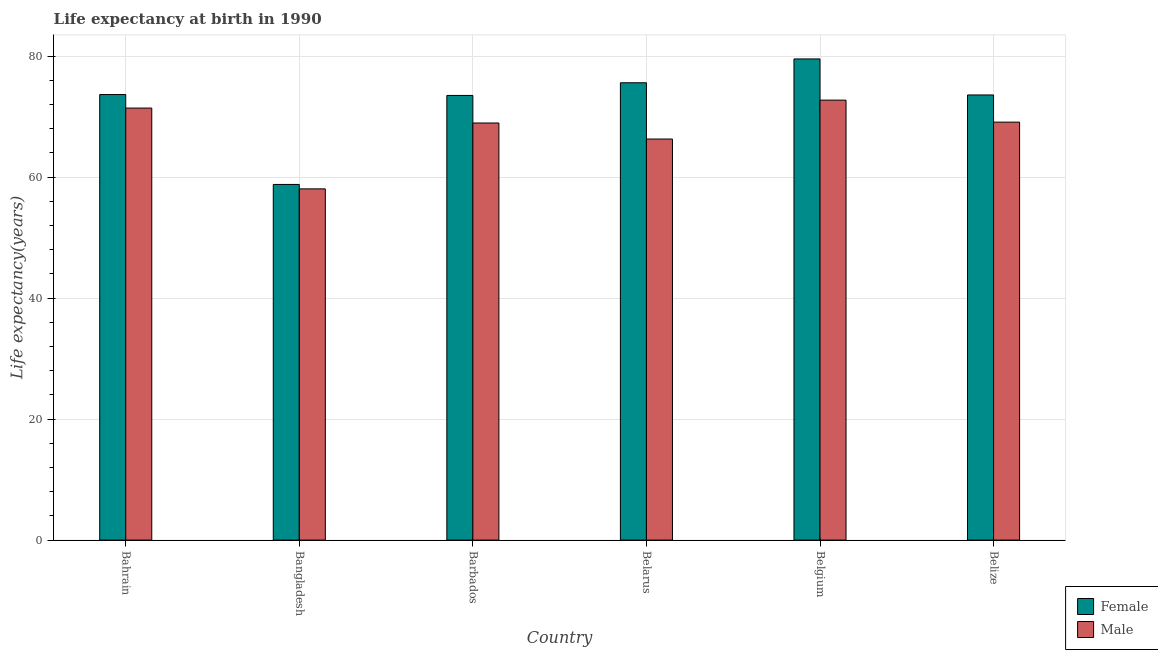Are the number of bars per tick equal to the number of legend labels?
Offer a very short reply. Yes. Are the number of bars on each tick of the X-axis equal?
Provide a short and direct response. Yes. How many bars are there on the 6th tick from the left?
Offer a terse response. 2. How many bars are there on the 3rd tick from the right?
Make the answer very short. 2. What is the label of the 4th group of bars from the left?
Offer a terse response. Belarus. What is the life expectancy(female) in Barbados?
Your answer should be very brief. 73.5. Across all countries, what is the maximum life expectancy(female)?
Provide a short and direct response. 79.54. Across all countries, what is the minimum life expectancy(male)?
Provide a short and direct response. 58.06. In which country was the life expectancy(female) minimum?
Your answer should be compact. Bangladesh. What is the total life expectancy(female) in the graph?
Provide a succinct answer. 434.67. What is the difference between the life expectancy(female) in Bangladesh and that in Belgium?
Make the answer very short. -20.75. What is the difference between the life expectancy(female) in Bangladesh and the life expectancy(male) in Belarus?
Make the answer very short. -7.51. What is the average life expectancy(male) per country?
Make the answer very short. 67.76. What is the difference between the life expectancy(female) and life expectancy(male) in Barbados?
Offer a terse response. 4.55. In how many countries, is the life expectancy(female) greater than 40 years?
Give a very brief answer. 6. What is the ratio of the life expectancy(male) in Bangladesh to that in Belize?
Your answer should be very brief. 0.84. What is the difference between the highest and the second highest life expectancy(male)?
Your response must be concise. 1.31. What is the difference between the highest and the lowest life expectancy(female)?
Keep it short and to the point. 20.75. Is the sum of the life expectancy(female) in Bangladesh and Barbados greater than the maximum life expectancy(male) across all countries?
Your answer should be compact. Yes. What does the 2nd bar from the left in Belgium represents?
Your response must be concise. Male. What does the 2nd bar from the right in Belarus represents?
Make the answer very short. Female. How many bars are there?
Your answer should be compact. 12. Are all the bars in the graph horizontal?
Keep it short and to the point. No. How many countries are there in the graph?
Offer a terse response. 6. What is the difference between two consecutive major ticks on the Y-axis?
Provide a succinct answer. 20. Are the values on the major ticks of Y-axis written in scientific E-notation?
Offer a terse response. No. Does the graph contain any zero values?
Provide a succinct answer. No. Does the graph contain grids?
Offer a terse response. Yes. Where does the legend appear in the graph?
Make the answer very short. Bottom right. What is the title of the graph?
Provide a succinct answer. Life expectancy at birth in 1990. What is the label or title of the X-axis?
Ensure brevity in your answer.  Country. What is the label or title of the Y-axis?
Your answer should be compact. Life expectancy(years). What is the Life expectancy(years) in Female in Bahrain?
Offer a very short reply. 73.65. What is the Life expectancy(years) of Male in Bahrain?
Make the answer very short. 71.42. What is the Life expectancy(years) in Female in Bangladesh?
Make the answer very short. 58.79. What is the Life expectancy(years) of Male in Bangladesh?
Offer a very short reply. 58.06. What is the Life expectancy(years) of Female in Barbados?
Offer a terse response. 73.5. What is the Life expectancy(years) in Male in Barbados?
Offer a terse response. 68.95. What is the Life expectancy(years) in Female in Belarus?
Ensure brevity in your answer.  75.6. What is the Life expectancy(years) of Male in Belarus?
Give a very brief answer. 66.3. What is the Life expectancy(years) in Female in Belgium?
Provide a succinct answer. 79.54. What is the Life expectancy(years) in Male in Belgium?
Your answer should be compact. 72.73. What is the Life expectancy(years) of Female in Belize?
Offer a very short reply. 73.58. What is the Life expectancy(years) in Male in Belize?
Provide a short and direct response. 69.09. Across all countries, what is the maximum Life expectancy(years) of Female?
Give a very brief answer. 79.54. Across all countries, what is the maximum Life expectancy(years) in Male?
Give a very brief answer. 72.73. Across all countries, what is the minimum Life expectancy(years) of Female?
Offer a very short reply. 58.79. Across all countries, what is the minimum Life expectancy(years) in Male?
Offer a very short reply. 58.06. What is the total Life expectancy(years) in Female in the graph?
Keep it short and to the point. 434.67. What is the total Life expectancy(years) of Male in the graph?
Give a very brief answer. 406.55. What is the difference between the Life expectancy(years) of Female in Bahrain and that in Bangladesh?
Provide a succinct answer. 14.86. What is the difference between the Life expectancy(years) of Male in Bahrain and that in Bangladesh?
Your response must be concise. 13.36. What is the difference between the Life expectancy(years) in Female in Bahrain and that in Barbados?
Your answer should be compact. 0.15. What is the difference between the Life expectancy(years) in Male in Bahrain and that in Barbados?
Give a very brief answer. 2.47. What is the difference between the Life expectancy(years) in Female in Bahrain and that in Belarus?
Make the answer very short. -1.95. What is the difference between the Life expectancy(years) in Male in Bahrain and that in Belarus?
Your answer should be very brief. 5.12. What is the difference between the Life expectancy(years) in Female in Bahrain and that in Belgium?
Provide a succinct answer. -5.89. What is the difference between the Life expectancy(years) of Male in Bahrain and that in Belgium?
Keep it short and to the point. -1.31. What is the difference between the Life expectancy(years) of Female in Bahrain and that in Belize?
Your answer should be very brief. 0.07. What is the difference between the Life expectancy(years) in Male in Bahrain and that in Belize?
Your response must be concise. 2.32. What is the difference between the Life expectancy(years) in Female in Bangladesh and that in Barbados?
Offer a very short reply. -14.71. What is the difference between the Life expectancy(years) in Male in Bangladesh and that in Barbados?
Your answer should be very brief. -10.89. What is the difference between the Life expectancy(years) in Female in Bangladesh and that in Belarus?
Your answer should be very brief. -16.81. What is the difference between the Life expectancy(years) of Male in Bangladesh and that in Belarus?
Your answer should be compact. -8.24. What is the difference between the Life expectancy(years) in Female in Bangladesh and that in Belgium?
Your answer should be compact. -20.75. What is the difference between the Life expectancy(years) in Male in Bangladesh and that in Belgium?
Provide a succinct answer. -14.67. What is the difference between the Life expectancy(years) of Female in Bangladesh and that in Belize?
Your answer should be very brief. -14.79. What is the difference between the Life expectancy(years) in Male in Bangladesh and that in Belize?
Keep it short and to the point. -11.03. What is the difference between the Life expectancy(years) in Female in Barbados and that in Belarus?
Provide a short and direct response. -2.1. What is the difference between the Life expectancy(years) of Male in Barbados and that in Belarus?
Make the answer very short. 2.65. What is the difference between the Life expectancy(years) of Female in Barbados and that in Belgium?
Offer a very short reply. -6.04. What is the difference between the Life expectancy(years) of Male in Barbados and that in Belgium?
Your response must be concise. -3.78. What is the difference between the Life expectancy(years) of Female in Barbados and that in Belize?
Give a very brief answer. -0.08. What is the difference between the Life expectancy(years) in Male in Barbados and that in Belize?
Keep it short and to the point. -0.14. What is the difference between the Life expectancy(years) in Female in Belarus and that in Belgium?
Your answer should be very brief. -3.94. What is the difference between the Life expectancy(years) in Male in Belarus and that in Belgium?
Give a very brief answer. -6.43. What is the difference between the Life expectancy(years) of Female in Belarus and that in Belize?
Ensure brevity in your answer.  2.02. What is the difference between the Life expectancy(years) of Male in Belarus and that in Belize?
Give a very brief answer. -2.79. What is the difference between the Life expectancy(years) in Female in Belgium and that in Belize?
Keep it short and to the point. 5.96. What is the difference between the Life expectancy(years) of Male in Belgium and that in Belize?
Keep it short and to the point. 3.64. What is the difference between the Life expectancy(years) in Female in Bahrain and the Life expectancy(years) in Male in Bangladesh?
Offer a terse response. 15.59. What is the difference between the Life expectancy(years) in Female in Bahrain and the Life expectancy(years) in Male in Barbados?
Offer a terse response. 4.7. What is the difference between the Life expectancy(years) in Female in Bahrain and the Life expectancy(years) in Male in Belarus?
Ensure brevity in your answer.  7.35. What is the difference between the Life expectancy(years) in Female in Bahrain and the Life expectancy(years) in Male in Belgium?
Make the answer very short. 0.92. What is the difference between the Life expectancy(years) in Female in Bahrain and the Life expectancy(years) in Male in Belize?
Give a very brief answer. 4.56. What is the difference between the Life expectancy(years) of Female in Bangladesh and the Life expectancy(years) of Male in Barbados?
Your answer should be very brief. -10.16. What is the difference between the Life expectancy(years) of Female in Bangladesh and the Life expectancy(years) of Male in Belarus?
Your answer should be very brief. -7.51. What is the difference between the Life expectancy(years) of Female in Bangladesh and the Life expectancy(years) of Male in Belgium?
Provide a succinct answer. -13.94. What is the difference between the Life expectancy(years) in Female in Bangladesh and the Life expectancy(years) in Male in Belize?
Keep it short and to the point. -10.3. What is the difference between the Life expectancy(years) in Female in Barbados and the Life expectancy(years) in Male in Belarus?
Make the answer very short. 7.21. What is the difference between the Life expectancy(years) in Female in Barbados and the Life expectancy(years) in Male in Belgium?
Offer a very short reply. 0.78. What is the difference between the Life expectancy(years) of Female in Barbados and the Life expectancy(years) of Male in Belize?
Your answer should be very brief. 4.41. What is the difference between the Life expectancy(years) in Female in Belarus and the Life expectancy(years) in Male in Belgium?
Keep it short and to the point. 2.87. What is the difference between the Life expectancy(years) in Female in Belarus and the Life expectancy(years) in Male in Belize?
Your response must be concise. 6.51. What is the difference between the Life expectancy(years) in Female in Belgium and the Life expectancy(years) in Male in Belize?
Ensure brevity in your answer.  10.45. What is the average Life expectancy(years) in Female per country?
Give a very brief answer. 72.45. What is the average Life expectancy(years) of Male per country?
Your answer should be compact. 67.76. What is the difference between the Life expectancy(years) of Female and Life expectancy(years) of Male in Bahrain?
Offer a very short reply. 2.23. What is the difference between the Life expectancy(years) in Female and Life expectancy(years) in Male in Bangladesh?
Keep it short and to the point. 0.73. What is the difference between the Life expectancy(years) in Female and Life expectancy(years) in Male in Barbados?
Provide a succinct answer. 4.55. What is the difference between the Life expectancy(years) of Female and Life expectancy(years) of Male in Belgium?
Ensure brevity in your answer.  6.81. What is the difference between the Life expectancy(years) of Female and Life expectancy(years) of Male in Belize?
Offer a very short reply. 4.49. What is the ratio of the Life expectancy(years) of Female in Bahrain to that in Bangladesh?
Keep it short and to the point. 1.25. What is the ratio of the Life expectancy(years) in Male in Bahrain to that in Bangladesh?
Ensure brevity in your answer.  1.23. What is the ratio of the Life expectancy(years) in Female in Bahrain to that in Barbados?
Keep it short and to the point. 1. What is the ratio of the Life expectancy(years) in Male in Bahrain to that in Barbados?
Make the answer very short. 1.04. What is the ratio of the Life expectancy(years) in Female in Bahrain to that in Belarus?
Your answer should be compact. 0.97. What is the ratio of the Life expectancy(years) of Male in Bahrain to that in Belarus?
Keep it short and to the point. 1.08. What is the ratio of the Life expectancy(years) of Female in Bahrain to that in Belgium?
Your answer should be compact. 0.93. What is the ratio of the Life expectancy(years) in Male in Bahrain to that in Belgium?
Ensure brevity in your answer.  0.98. What is the ratio of the Life expectancy(years) in Male in Bahrain to that in Belize?
Provide a succinct answer. 1.03. What is the ratio of the Life expectancy(years) of Female in Bangladesh to that in Barbados?
Offer a terse response. 0.8. What is the ratio of the Life expectancy(years) in Male in Bangladesh to that in Barbados?
Give a very brief answer. 0.84. What is the ratio of the Life expectancy(years) in Female in Bangladesh to that in Belarus?
Keep it short and to the point. 0.78. What is the ratio of the Life expectancy(years) in Male in Bangladesh to that in Belarus?
Provide a short and direct response. 0.88. What is the ratio of the Life expectancy(years) of Female in Bangladesh to that in Belgium?
Your answer should be very brief. 0.74. What is the ratio of the Life expectancy(years) in Male in Bangladesh to that in Belgium?
Offer a terse response. 0.8. What is the ratio of the Life expectancy(years) in Female in Bangladesh to that in Belize?
Your answer should be compact. 0.8. What is the ratio of the Life expectancy(years) of Male in Bangladesh to that in Belize?
Your response must be concise. 0.84. What is the ratio of the Life expectancy(years) of Female in Barbados to that in Belarus?
Your answer should be compact. 0.97. What is the ratio of the Life expectancy(years) of Male in Barbados to that in Belarus?
Offer a very short reply. 1.04. What is the ratio of the Life expectancy(years) of Female in Barbados to that in Belgium?
Keep it short and to the point. 0.92. What is the ratio of the Life expectancy(years) in Male in Barbados to that in Belgium?
Provide a short and direct response. 0.95. What is the ratio of the Life expectancy(years) of Male in Barbados to that in Belize?
Ensure brevity in your answer.  1. What is the ratio of the Life expectancy(years) in Female in Belarus to that in Belgium?
Offer a very short reply. 0.95. What is the ratio of the Life expectancy(years) of Male in Belarus to that in Belgium?
Your response must be concise. 0.91. What is the ratio of the Life expectancy(years) in Female in Belarus to that in Belize?
Provide a short and direct response. 1.03. What is the ratio of the Life expectancy(years) of Male in Belarus to that in Belize?
Your response must be concise. 0.96. What is the ratio of the Life expectancy(years) of Female in Belgium to that in Belize?
Your answer should be compact. 1.08. What is the ratio of the Life expectancy(years) of Male in Belgium to that in Belize?
Ensure brevity in your answer.  1.05. What is the difference between the highest and the second highest Life expectancy(years) of Female?
Offer a terse response. 3.94. What is the difference between the highest and the second highest Life expectancy(years) in Male?
Give a very brief answer. 1.31. What is the difference between the highest and the lowest Life expectancy(years) in Female?
Ensure brevity in your answer.  20.75. What is the difference between the highest and the lowest Life expectancy(years) in Male?
Give a very brief answer. 14.67. 